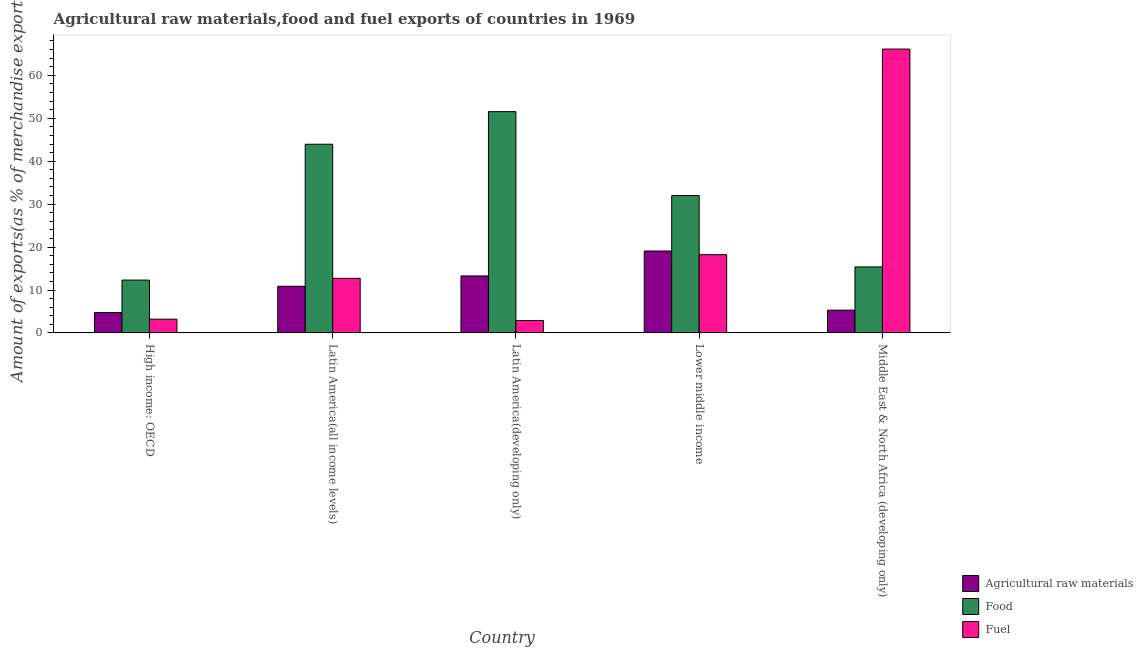How many different coloured bars are there?
Your answer should be compact. 3. How many groups of bars are there?
Offer a very short reply. 5. Are the number of bars per tick equal to the number of legend labels?
Keep it short and to the point. Yes. How many bars are there on the 3rd tick from the left?
Make the answer very short. 3. What is the label of the 5th group of bars from the left?
Make the answer very short. Middle East & North Africa (developing only). In how many cases, is the number of bars for a given country not equal to the number of legend labels?
Provide a short and direct response. 0. What is the percentage of raw materials exports in Lower middle income?
Your answer should be compact. 19.08. Across all countries, what is the maximum percentage of fuel exports?
Provide a short and direct response. 66.11. Across all countries, what is the minimum percentage of raw materials exports?
Offer a very short reply. 4.74. In which country was the percentage of food exports maximum?
Offer a very short reply. Latin America(developing only). In which country was the percentage of food exports minimum?
Provide a short and direct response. High income: OECD. What is the total percentage of raw materials exports in the graph?
Your response must be concise. 53.26. What is the difference between the percentage of food exports in Latin America(all income levels) and that in Latin America(developing only)?
Ensure brevity in your answer.  -7.58. What is the difference between the percentage of fuel exports in Latin America(all income levels) and the percentage of raw materials exports in Latin America(developing only)?
Keep it short and to the point. -0.56. What is the average percentage of food exports per country?
Your answer should be very brief. 31.04. What is the difference between the percentage of fuel exports and percentage of food exports in Lower middle income?
Provide a succinct answer. -13.78. What is the ratio of the percentage of food exports in Latin America(all income levels) to that in Latin America(developing only)?
Offer a very short reply. 0.85. Is the percentage of food exports in High income: OECD less than that in Latin America(all income levels)?
Your answer should be very brief. Yes. Is the difference between the percentage of raw materials exports in Latin America(all income levels) and Latin America(developing only) greater than the difference between the percentage of food exports in Latin America(all income levels) and Latin America(developing only)?
Keep it short and to the point. Yes. What is the difference between the highest and the second highest percentage of fuel exports?
Your answer should be compact. 47.89. What is the difference between the highest and the lowest percentage of fuel exports?
Offer a terse response. 63.21. Is the sum of the percentage of fuel exports in High income: OECD and Middle East & North Africa (developing only) greater than the maximum percentage of food exports across all countries?
Your answer should be very brief. Yes. What does the 1st bar from the left in High income: OECD represents?
Ensure brevity in your answer.  Agricultural raw materials. What does the 3rd bar from the right in Lower middle income represents?
Make the answer very short. Agricultural raw materials. Does the graph contain any zero values?
Your answer should be very brief. No. Does the graph contain grids?
Your answer should be compact. No. Where does the legend appear in the graph?
Your response must be concise. Bottom right. How are the legend labels stacked?
Provide a short and direct response. Vertical. What is the title of the graph?
Offer a very short reply. Agricultural raw materials,food and fuel exports of countries in 1969. What is the label or title of the X-axis?
Your answer should be compact. Country. What is the label or title of the Y-axis?
Give a very brief answer. Amount of exports(as % of merchandise exports). What is the Amount of exports(as % of merchandise exports) in Agricultural raw materials in High income: OECD?
Provide a short and direct response. 4.74. What is the Amount of exports(as % of merchandise exports) in Food in High income: OECD?
Your response must be concise. 12.31. What is the Amount of exports(as % of merchandise exports) of Fuel in High income: OECD?
Provide a succinct answer. 3.2. What is the Amount of exports(as % of merchandise exports) in Agricultural raw materials in Latin America(all income levels)?
Provide a short and direct response. 10.86. What is the Amount of exports(as % of merchandise exports) in Food in Latin America(all income levels)?
Your answer should be very brief. 43.95. What is the Amount of exports(as % of merchandise exports) in Fuel in Latin America(all income levels)?
Make the answer very short. 12.71. What is the Amount of exports(as % of merchandise exports) of Agricultural raw materials in Latin America(developing only)?
Make the answer very short. 13.27. What is the Amount of exports(as % of merchandise exports) in Food in Latin America(developing only)?
Your answer should be very brief. 51.54. What is the Amount of exports(as % of merchandise exports) of Fuel in Latin America(developing only)?
Ensure brevity in your answer.  2.9. What is the Amount of exports(as % of merchandise exports) in Agricultural raw materials in Lower middle income?
Your answer should be very brief. 19.08. What is the Amount of exports(as % of merchandise exports) of Food in Lower middle income?
Your answer should be compact. 32. What is the Amount of exports(as % of merchandise exports) in Fuel in Lower middle income?
Give a very brief answer. 18.22. What is the Amount of exports(as % of merchandise exports) of Agricultural raw materials in Middle East & North Africa (developing only)?
Provide a succinct answer. 5.3. What is the Amount of exports(as % of merchandise exports) in Food in Middle East & North Africa (developing only)?
Ensure brevity in your answer.  15.38. What is the Amount of exports(as % of merchandise exports) in Fuel in Middle East & North Africa (developing only)?
Keep it short and to the point. 66.11. Across all countries, what is the maximum Amount of exports(as % of merchandise exports) of Agricultural raw materials?
Make the answer very short. 19.08. Across all countries, what is the maximum Amount of exports(as % of merchandise exports) in Food?
Your response must be concise. 51.54. Across all countries, what is the maximum Amount of exports(as % of merchandise exports) of Fuel?
Keep it short and to the point. 66.11. Across all countries, what is the minimum Amount of exports(as % of merchandise exports) of Agricultural raw materials?
Your answer should be very brief. 4.74. Across all countries, what is the minimum Amount of exports(as % of merchandise exports) of Food?
Your response must be concise. 12.31. Across all countries, what is the minimum Amount of exports(as % of merchandise exports) in Fuel?
Your answer should be very brief. 2.9. What is the total Amount of exports(as % of merchandise exports) in Agricultural raw materials in the graph?
Offer a terse response. 53.26. What is the total Amount of exports(as % of merchandise exports) in Food in the graph?
Offer a very short reply. 155.18. What is the total Amount of exports(as % of merchandise exports) of Fuel in the graph?
Ensure brevity in your answer.  103.15. What is the difference between the Amount of exports(as % of merchandise exports) in Agricultural raw materials in High income: OECD and that in Latin America(all income levels)?
Make the answer very short. -6.12. What is the difference between the Amount of exports(as % of merchandise exports) in Food in High income: OECD and that in Latin America(all income levels)?
Ensure brevity in your answer.  -31.64. What is the difference between the Amount of exports(as % of merchandise exports) in Fuel in High income: OECD and that in Latin America(all income levels)?
Keep it short and to the point. -9.51. What is the difference between the Amount of exports(as % of merchandise exports) in Agricultural raw materials in High income: OECD and that in Latin America(developing only)?
Offer a very short reply. -8.53. What is the difference between the Amount of exports(as % of merchandise exports) in Food in High income: OECD and that in Latin America(developing only)?
Offer a very short reply. -39.22. What is the difference between the Amount of exports(as % of merchandise exports) in Fuel in High income: OECD and that in Latin America(developing only)?
Offer a very short reply. 0.3. What is the difference between the Amount of exports(as % of merchandise exports) in Agricultural raw materials in High income: OECD and that in Lower middle income?
Offer a terse response. -14.34. What is the difference between the Amount of exports(as % of merchandise exports) in Food in High income: OECD and that in Lower middle income?
Your answer should be very brief. -19.69. What is the difference between the Amount of exports(as % of merchandise exports) of Fuel in High income: OECD and that in Lower middle income?
Offer a terse response. -15.02. What is the difference between the Amount of exports(as % of merchandise exports) of Agricultural raw materials in High income: OECD and that in Middle East & North Africa (developing only)?
Keep it short and to the point. -0.56. What is the difference between the Amount of exports(as % of merchandise exports) in Food in High income: OECD and that in Middle East & North Africa (developing only)?
Provide a short and direct response. -3.06. What is the difference between the Amount of exports(as % of merchandise exports) in Fuel in High income: OECD and that in Middle East & North Africa (developing only)?
Make the answer very short. -62.91. What is the difference between the Amount of exports(as % of merchandise exports) of Agricultural raw materials in Latin America(all income levels) and that in Latin America(developing only)?
Ensure brevity in your answer.  -2.41. What is the difference between the Amount of exports(as % of merchandise exports) in Food in Latin America(all income levels) and that in Latin America(developing only)?
Your answer should be compact. -7.58. What is the difference between the Amount of exports(as % of merchandise exports) of Fuel in Latin America(all income levels) and that in Latin America(developing only)?
Make the answer very short. 9.82. What is the difference between the Amount of exports(as % of merchandise exports) of Agricultural raw materials in Latin America(all income levels) and that in Lower middle income?
Keep it short and to the point. -8.22. What is the difference between the Amount of exports(as % of merchandise exports) of Food in Latin America(all income levels) and that in Lower middle income?
Offer a very short reply. 11.95. What is the difference between the Amount of exports(as % of merchandise exports) of Fuel in Latin America(all income levels) and that in Lower middle income?
Offer a very short reply. -5.51. What is the difference between the Amount of exports(as % of merchandise exports) in Agricultural raw materials in Latin America(all income levels) and that in Middle East & North Africa (developing only)?
Offer a terse response. 5.56. What is the difference between the Amount of exports(as % of merchandise exports) of Food in Latin America(all income levels) and that in Middle East & North Africa (developing only)?
Keep it short and to the point. 28.58. What is the difference between the Amount of exports(as % of merchandise exports) in Fuel in Latin America(all income levels) and that in Middle East & North Africa (developing only)?
Provide a short and direct response. -53.4. What is the difference between the Amount of exports(as % of merchandise exports) in Agricultural raw materials in Latin America(developing only) and that in Lower middle income?
Provide a succinct answer. -5.8. What is the difference between the Amount of exports(as % of merchandise exports) of Food in Latin America(developing only) and that in Lower middle income?
Your answer should be very brief. 19.53. What is the difference between the Amount of exports(as % of merchandise exports) in Fuel in Latin America(developing only) and that in Lower middle income?
Give a very brief answer. -15.32. What is the difference between the Amount of exports(as % of merchandise exports) of Agricultural raw materials in Latin America(developing only) and that in Middle East & North Africa (developing only)?
Your answer should be compact. 7.97. What is the difference between the Amount of exports(as % of merchandise exports) of Food in Latin America(developing only) and that in Middle East & North Africa (developing only)?
Your answer should be compact. 36.16. What is the difference between the Amount of exports(as % of merchandise exports) in Fuel in Latin America(developing only) and that in Middle East & North Africa (developing only)?
Your response must be concise. -63.21. What is the difference between the Amount of exports(as % of merchandise exports) in Agricultural raw materials in Lower middle income and that in Middle East & North Africa (developing only)?
Provide a succinct answer. 13.77. What is the difference between the Amount of exports(as % of merchandise exports) of Food in Lower middle income and that in Middle East & North Africa (developing only)?
Your answer should be very brief. 16.63. What is the difference between the Amount of exports(as % of merchandise exports) in Fuel in Lower middle income and that in Middle East & North Africa (developing only)?
Provide a succinct answer. -47.89. What is the difference between the Amount of exports(as % of merchandise exports) in Agricultural raw materials in High income: OECD and the Amount of exports(as % of merchandise exports) in Food in Latin America(all income levels)?
Offer a very short reply. -39.21. What is the difference between the Amount of exports(as % of merchandise exports) of Agricultural raw materials in High income: OECD and the Amount of exports(as % of merchandise exports) of Fuel in Latin America(all income levels)?
Make the answer very short. -7.97. What is the difference between the Amount of exports(as % of merchandise exports) of Food in High income: OECD and the Amount of exports(as % of merchandise exports) of Fuel in Latin America(all income levels)?
Offer a very short reply. -0.4. What is the difference between the Amount of exports(as % of merchandise exports) of Agricultural raw materials in High income: OECD and the Amount of exports(as % of merchandise exports) of Food in Latin America(developing only)?
Give a very brief answer. -46.79. What is the difference between the Amount of exports(as % of merchandise exports) of Agricultural raw materials in High income: OECD and the Amount of exports(as % of merchandise exports) of Fuel in Latin America(developing only)?
Ensure brevity in your answer.  1.84. What is the difference between the Amount of exports(as % of merchandise exports) in Food in High income: OECD and the Amount of exports(as % of merchandise exports) in Fuel in Latin America(developing only)?
Offer a very short reply. 9.41. What is the difference between the Amount of exports(as % of merchandise exports) of Agricultural raw materials in High income: OECD and the Amount of exports(as % of merchandise exports) of Food in Lower middle income?
Your response must be concise. -27.26. What is the difference between the Amount of exports(as % of merchandise exports) of Agricultural raw materials in High income: OECD and the Amount of exports(as % of merchandise exports) of Fuel in Lower middle income?
Your answer should be compact. -13.48. What is the difference between the Amount of exports(as % of merchandise exports) in Food in High income: OECD and the Amount of exports(as % of merchandise exports) in Fuel in Lower middle income?
Your answer should be very brief. -5.91. What is the difference between the Amount of exports(as % of merchandise exports) in Agricultural raw materials in High income: OECD and the Amount of exports(as % of merchandise exports) in Food in Middle East & North Africa (developing only)?
Your answer should be compact. -10.63. What is the difference between the Amount of exports(as % of merchandise exports) of Agricultural raw materials in High income: OECD and the Amount of exports(as % of merchandise exports) of Fuel in Middle East & North Africa (developing only)?
Offer a very short reply. -61.37. What is the difference between the Amount of exports(as % of merchandise exports) in Food in High income: OECD and the Amount of exports(as % of merchandise exports) in Fuel in Middle East & North Africa (developing only)?
Your answer should be compact. -53.8. What is the difference between the Amount of exports(as % of merchandise exports) of Agricultural raw materials in Latin America(all income levels) and the Amount of exports(as % of merchandise exports) of Food in Latin America(developing only)?
Ensure brevity in your answer.  -40.68. What is the difference between the Amount of exports(as % of merchandise exports) of Agricultural raw materials in Latin America(all income levels) and the Amount of exports(as % of merchandise exports) of Fuel in Latin America(developing only)?
Offer a terse response. 7.96. What is the difference between the Amount of exports(as % of merchandise exports) of Food in Latin America(all income levels) and the Amount of exports(as % of merchandise exports) of Fuel in Latin America(developing only)?
Offer a very short reply. 41.05. What is the difference between the Amount of exports(as % of merchandise exports) in Agricultural raw materials in Latin America(all income levels) and the Amount of exports(as % of merchandise exports) in Food in Lower middle income?
Offer a terse response. -21.14. What is the difference between the Amount of exports(as % of merchandise exports) of Agricultural raw materials in Latin America(all income levels) and the Amount of exports(as % of merchandise exports) of Fuel in Lower middle income?
Provide a short and direct response. -7.36. What is the difference between the Amount of exports(as % of merchandise exports) in Food in Latin America(all income levels) and the Amount of exports(as % of merchandise exports) in Fuel in Lower middle income?
Provide a succinct answer. 25.73. What is the difference between the Amount of exports(as % of merchandise exports) of Agricultural raw materials in Latin America(all income levels) and the Amount of exports(as % of merchandise exports) of Food in Middle East & North Africa (developing only)?
Provide a succinct answer. -4.51. What is the difference between the Amount of exports(as % of merchandise exports) in Agricultural raw materials in Latin America(all income levels) and the Amount of exports(as % of merchandise exports) in Fuel in Middle East & North Africa (developing only)?
Your answer should be very brief. -55.25. What is the difference between the Amount of exports(as % of merchandise exports) of Food in Latin America(all income levels) and the Amount of exports(as % of merchandise exports) of Fuel in Middle East & North Africa (developing only)?
Ensure brevity in your answer.  -22.16. What is the difference between the Amount of exports(as % of merchandise exports) of Agricultural raw materials in Latin America(developing only) and the Amount of exports(as % of merchandise exports) of Food in Lower middle income?
Provide a succinct answer. -18.73. What is the difference between the Amount of exports(as % of merchandise exports) in Agricultural raw materials in Latin America(developing only) and the Amount of exports(as % of merchandise exports) in Fuel in Lower middle income?
Keep it short and to the point. -4.95. What is the difference between the Amount of exports(as % of merchandise exports) in Food in Latin America(developing only) and the Amount of exports(as % of merchandise exports) in Fuel in Lower middle income?
Offer a very short reply. 33.31. What is the difference between the Amount of exports(as % of merchandise exports) of Agricultural raw materials in Latin America(developing only) and the Amount of exports(as % of merchandise exports) of Food in Middle East & North Africa (developing only)?
Provide a short and direct response. -2.1. What is the difference between the Amount of exports(as % of merchandise exports) of Agricultural raw materials in Latin America(developing only) and the Amount of exports(as % of merchandise exports) of Fuel in Middle East & North Africa (developing only)?
Provide a succinct answer. -52.84. What is the difference between the Amount of exports(as % of merchandise exports) of Food in Latin America(developing only) and the Amount of exports(as % of merchandise exports) of Fuel in Middle East & North Africa (developing only)?
Offer a terse response. -14.58. What is the difference between the Amount of exports(as % of merchandise exports) of Agricultural raw materials in Lower middle income and the Amount of exports(as % of merchandise exports) of Food in Middle East & North Africa (developing only)?
Your response must be concise. 3.7. What is the difference between the Amount of exports(as % of merchandise exports) in Agricultural raw materials in Lower middle income and the Amount of exports(as % of merchandise exports) in Fuel in Middle East & North Africa (developing only)?
Provide a short and direct response. -47.03. What is the difference between the Amount of exports(as % of merchandise exports) in Food in Lower middle income and the Amount of exports(as % of merchandise exports) in Fuel in Middle East & North Africa (developing only)?
Offer a very short reply. -34.11. What is the average Amount of exports(as % of merchandise exports) in Agricultural raw materials per country?
Give a very brief answer. 10.65. What is the average Amount of exports(as % of merchandise exports) in Food per country?
Make the answer very short. 31.04. What is the average Amount of exports(as % of merchandise exports) of Fuel per country?
Your answer should be very brief. 20.63. What is the difference between the Amount of exports(as % of merchandise exports) of Agricultural raw materials and Amount of exports(as % of merchandise exports) of Food in High income: OECD?
Ensure brevity in your answer.  -7.57. What is the difference between the Amount of exports(as % of merchandise exports) in Agricultural raw materials and Amount of exports(as % of merchandise exports) in Fuel in High income: OECD?
Keep it short and to the point. 1.54. What is the difference between the Amount of exports(as % of merchandise exports) in Food and Amount of exports(as % of merchandise exports) in Fuel in High income: OECD?
Offer a terse response. 9.11. What is the difference between the Amount of exports(as % of merchandise exports) of Agricultural raw materials and Amount of exports(as % of merchandise exports) of Food in Latin America(all income levels)?
Make the answer very short. -33.09. What is the difference between the Amount of exports(as % of merchandise exports) in Agricultural raw materials and Amount of exports(as % of merchandise exports) in Fuel in Latin America(all income levels)?
Provide a short and direct response. -1.85. What is the difference between the Amount of exports(as % of merchandise exports) in Food and Amount of exports(as % of merchandise exports) in Fuel in Latin America(all income levels)?
Your answer should be very brief. 31.24. What is the difference between the Amount of exports(as % of merchandise exports) of Agricultural raw materials and Amount of exports(as % of merchandise exports) of Food in Latin America(developing only)?
Provide a short and direct response. -38.26. What is the difference between the Amount of exports(as % of merchandise exports) in Agricultural raw materials and Amount of exports(as % of merchandise exports) in Fuel in Latin America(developing only)?
Your answer should be very brief. 10.37. What is the difference between the Amount of exports(as % of merchandise exports) of Food and Amount of exports(as % of merchandise exports) of Fuel in Latin America(developing only)?
Give a very brief answer. 48.64. What is the difference between the Amount of exports(as % of merchandise exports) of Agricultural raw materials and Amount of exports(as % of merchandise exports) of Food in Lower middle income?
Keep it short and to the point. -12.92. What is the difference between the Amount of exports(as % of merchandise exports) of Agricultural raw materials and Amount of exports(as % of merchandise exports) of Fuel in Lower middle income?
Give a very brief answer. 0.86. What is the difference between the Amount of exports(as % of merchandise exports) of Food and Amount of exports(as % of merchandise exports) of Fuel in Lower middle income?
Offer a very short reply. 13.78. What is the difference between the Amount of exports(as % of merchandise exports) in Agricultural raw materials and Amount of exports(as % of merchandise exports) in Food in Middle East & North Africa (developing only)?
Your response must be concise. -10.07. What is the difference between the Amount of exports(as % of merchandise exports) in Agricultural raw materials and Amount of exports(as % of merchandise exports) in Fuel in Middle East & North Africa (developing only)?
Offer a very short reply. -60.81. What is the difference between the Amount of exports(as % of merchandise exports) in Food and Amount of exports(as % of merchandise exports) in Fuel in Middle East & North Africa (developing only)?
Your answer should be compact. -50.74. What is the ratio of the Amount of exports(as % of merchandise exports) of Agricultural raw materials in High income: OECD to that in Latin America(all income levels)?
Give a very brief answer. 0.44. What is the ratio of the Amount of exports(as % of merchandise exports) in Food in High income: OECD to that in Latin America(all income levels)?
Your response must be concise. 0.28. What is the ratio of the Amount of exports(as % of merchandise exports) of Fuel in High income: OECD to that in Latin America(all income levels)?
Your answer should be compact. 0.25. What is the ratio of the Amount of exports(as % of merchandise exports) of Agricultural raw materials in High income: OECD to that in Latin America(developing only)?
Your answer should be compact. 0.36. What is the ratio of the Amount of exports(as % of merchandise exports) of Food in High income: OECD to that in Latin America(developing only)?
Offer a very short reply. 0.24. What is the ratio of the Amount of exports(as % of merchandise exports) of Fuel in High income: OECD to that in Latin America(developing only)?
Keep it short and to the point. 1.1. What is the ratio of the Amount of exports(as % of merchandise exports) of Agricultural raw materials in High income: OECD to that in Lower middle income?
Provide a short and direct response. 0.25. What is the ratio of the Amount of exports(as % of merchandise exports) in Food in High income: OECD to that in Lower middle income?
Your answer should be compact. 0.38. What is the ratio of the Amount of exports(as % of merchandise exports) in Fuel in High income: OECD to that in Lower middle income?
Provide a succinct answer. 0.18. What is the ratio of the Amount of exports(as % of merchandise exports) in Agricultural raw materials in High income: OECD to that in Middle East & North Africa (developing only)?
Offer a terse response. 0.89. What is the ratio of the Amount of exports(as % of merchandise exports) in Food in High income: OECD to that in Middle East & North Africa (developing only)?
Provide a short and direct response. 0.8. What is the ratio of the Amount of exports(as % of merchandise exports) of Fuel in High income: OECD to that in Middle East & North Africa (developing only)?
Ensure brevity in your answer.  0.05. What is the ratio of the Amount of exports(as % of merchandise exports) in Agricultural raw materials in Latin America(all income levels) to that in Latin America(developing only)?
Offer a very short reply. 0.82. What is the ratio of the Amount of exports(as % of merchandise exports) in Food in Latin America(all income levels) to that in Latin America(developing only)?
Provide a short and direct response. 0.85. What is the ratio of the Amount of exports(as % of merchandise exports) of Fuel in Latin America(all income levels) to that in Latin America(developing only)?
Provide a succinct answer. 4.39. What is the ratio of the Amount of exports(as % of merchandise exports) in Agricultural raw materials in Latin America(all income levels) to that in Lower middle income?
Ensure brevity in your answer.  0.57. What is the ratio of the Amount of exports(as % of merchandise exports) in Food in Latin America(all income levels) to that in Lower middle income?
Provide a short and direct response. 1.37. What is the ratio of the Amount of exports(as % of merchandise exports) of Fuel in Latin America(all income levels) to that in Lower middle income?
Ensure brevity in your answer.  0.7. What is the ratio of the Amount of exports(as % of merchandise exports) of Agricultural raw materials in Latin America(all income levels) to that in Middle East & North Africa (developing only)?
Your answer should be compact. 2.05. What is the ratio of the Amount of exports(as % of merchandise exports) of Food in Latin America(all income levels) to that in Middle East & North Africa (developing only)?
Provide a succinct answer. 2.86. What is the ratio of the Amount of exports(as % of merchandise exports) of Fuel in Latin America(all income levels) to that in Middle East & North Africa (developing only)?
Provide a short and direct response. 0.19. What is the ratio of the Amount of exports(as % of merchandise exports) of Agricultural raw materials in Latin America(developing only) to that in Lower middle income?
Keep it short and to the point. 0.7. What is the ratio of the Amount of exports(as % of merchandise exports) in Food in Latin America(developing only) to that in Lower middle income?
Offer a very short reply. 1.61. What is the ratio of the Amount of exports(as % of merchandise exports) in Fuel in Latin America(developing only) to that in Lower middle income?
Offer a terse response. 0.16. What is the ratio of the Amount of exports(as % of merchandise exports) of Agricultural raw materials in Latin America(developing only) to that in Middle East & North Africa (developing only)?
Keep it short and to the point. 2.5. What is the ratio of the Amount of exports(as % of merchandise exports) of Food in Latin America(developing only) to that in Middle East & North Africa (developing only)?
Your answer should be compact. 3.35. What is the ratio of the Amount of exports(as % of merchandise exports) in Fuel in Latin America(developing only) to that in Middle East & North Africa (developing only)?
Make the answer very short. 0.04. What is the ratio of the Amount of exports(as % of merchandise exports) of Agricultural raw materials in Lower middle income to that in Middle East & North Africa (developing only)?
Provide a succinct answer. 3.6. What is the ratio of the Amount of exports(as % of merchandise exports) in Food in Lower middle income to that in Middle East & North Africa (developing only)?
Your answer should be very brief. 2.08. What is the ratio of the Amount of exports(as % of merchandise exports) of Fuel in Lower middle income to that in Middle East & North Africa (developing only)?
Give a very brief answer. 0.28. What is the difference between the highest and the second highest Amount of exports(as % of merchandise exports) in Agricultural raw materials?
Offer a very short reply. 5.8. What is the difference between the highest and the second highest Amount of exports(as % of merchandise exports) in Food?
Your answer should be very brief. 7.58. What is the difference between the highest and the second highest Amount of exports(as % of merchandise exports) of Fuel?
Provide a short and direct response. 47.89. What is the difference between the highest and the lowest Amount of exports(as % of merchandise exports) in Agricultural raw materials?
Provide a short and direct response. 14.34. What is the difference between the highest and the lowest Amount of exports(as % of merchandise exports) in Food?
Your answer should be very brief. 39.22. What is the difference between the highest and the lowest Amount of exports(as % of merchandise exports) of Fuel?
Offer a very short reply. 63.21. 